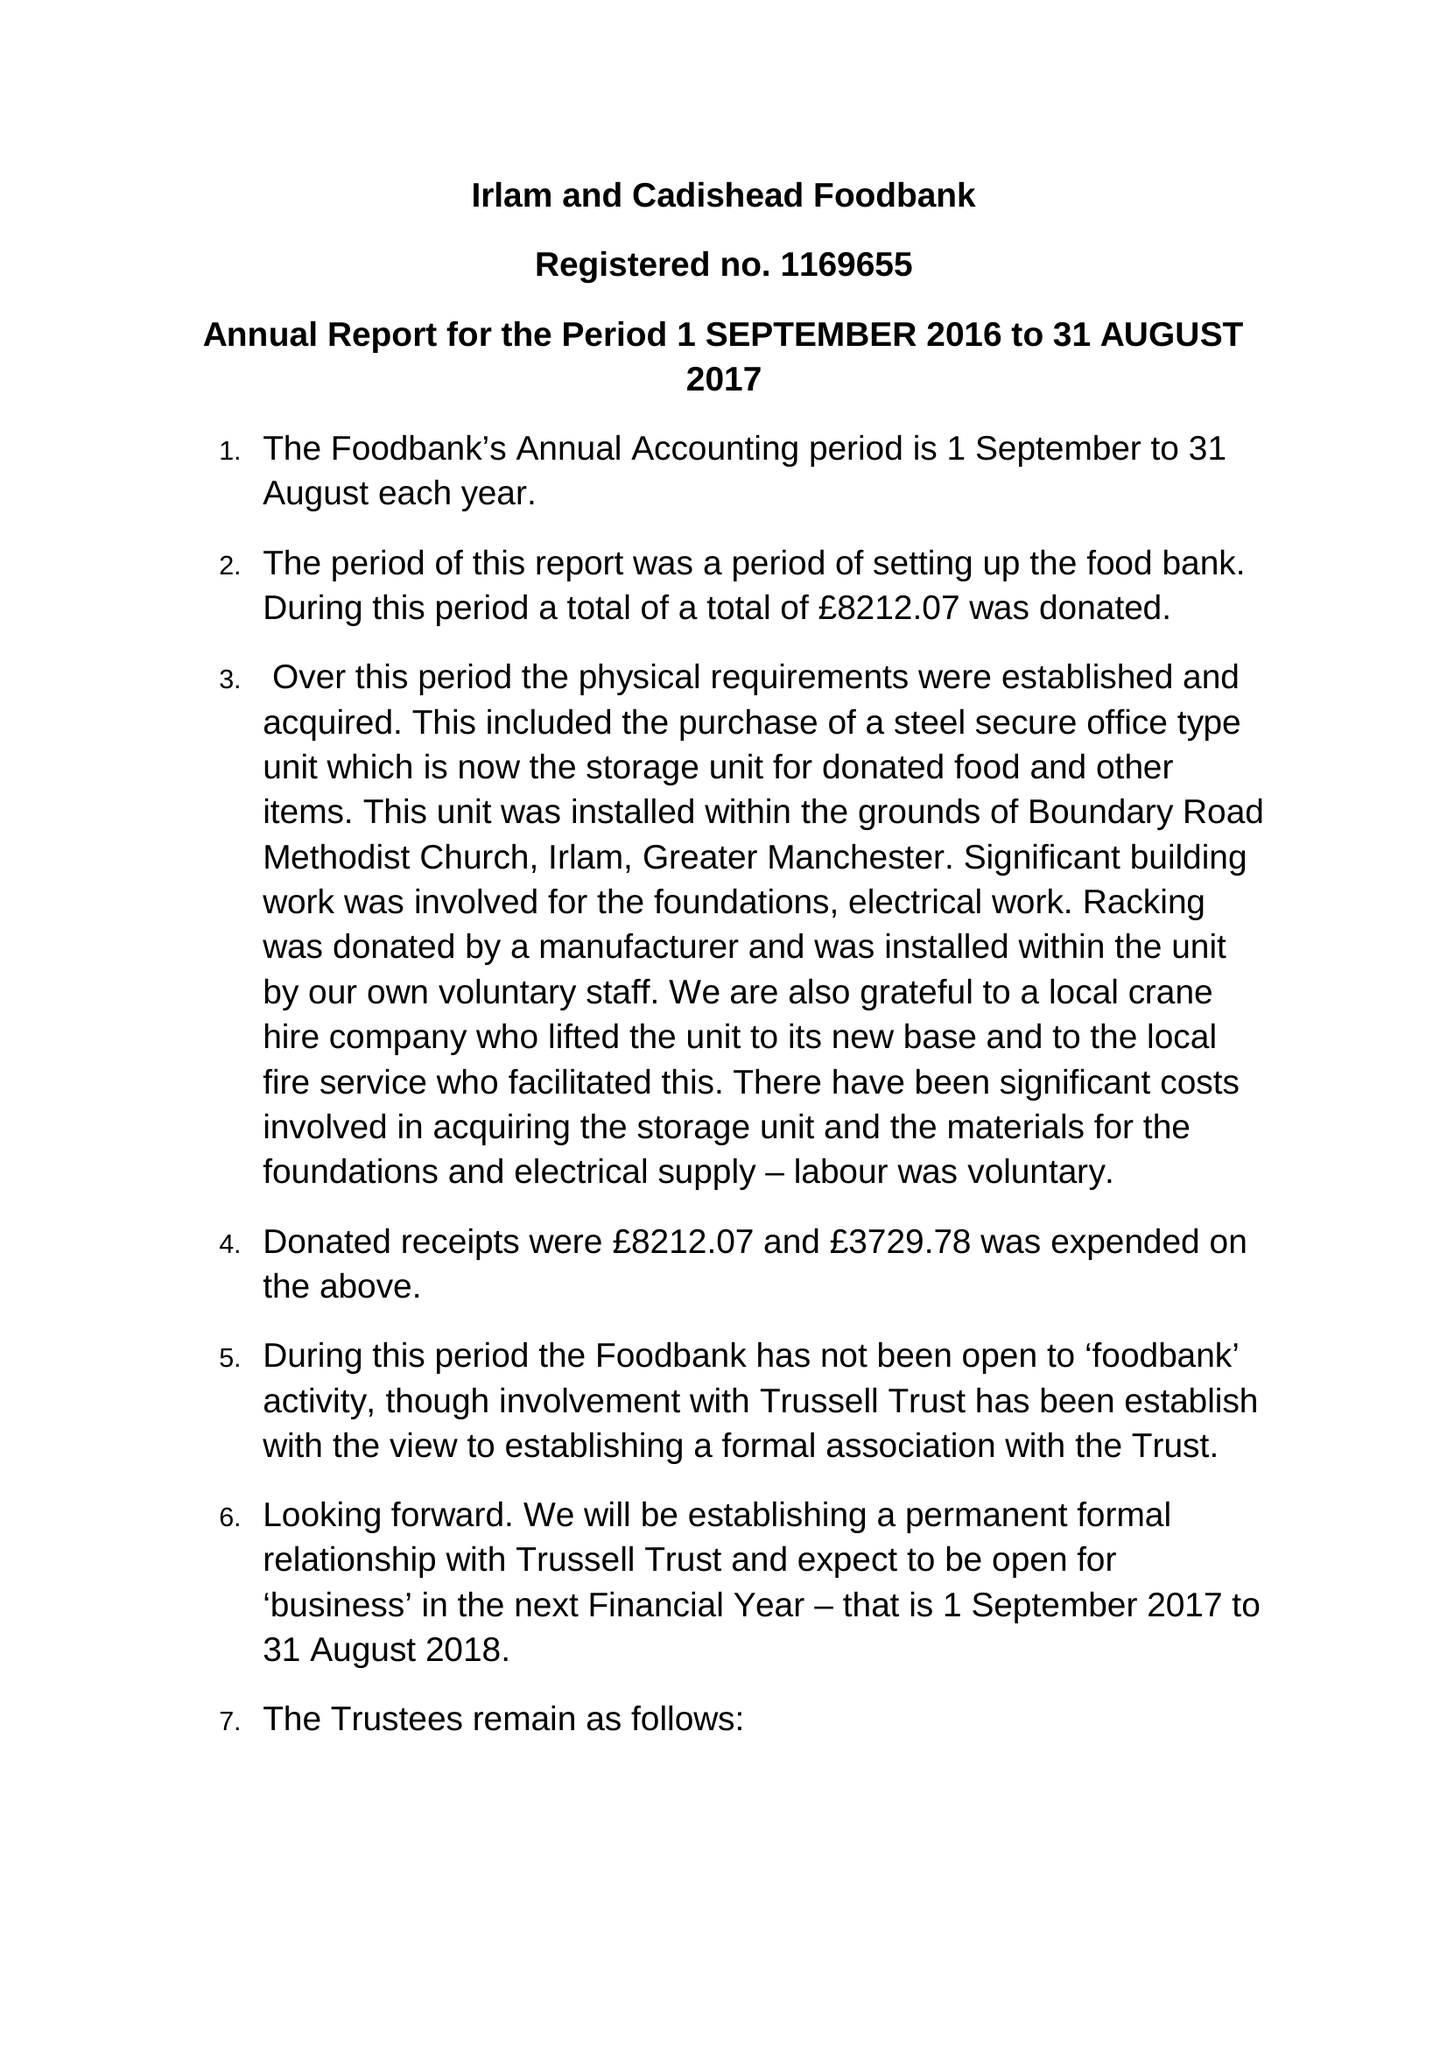What is the value for the address__post_town?
Answer the question using a single word or phrase. MANCHESTER 